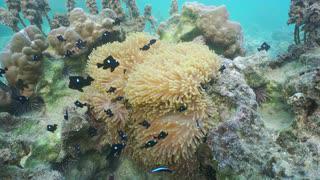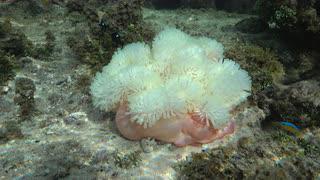The first image is the image on the left, the second image is the image on the right. Analyze the images presented: Is the assertion "there are black fish with a white spot swimming around the reef" valid? Answer yes or no. Yes. 